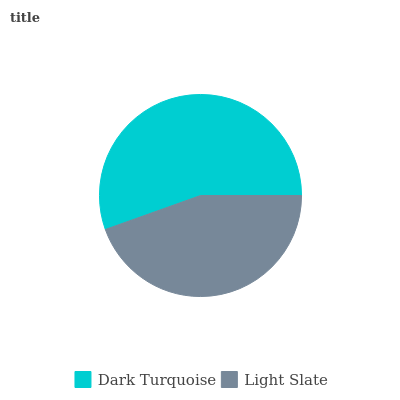Is Light Slate the minimum?
Answer yes or no. Yes. Is Dark Turquoise the maximum?
Answer yes or no. Yes. Is Light Slate the maximum?
Answer yes or no. No. Is Dark Turquoise greater than Light Slate?
Answer yes or no. Yes. Is Light Slate less than Dark Turquoise?
Answer yes or no. Yes. Is Light Slate greater than Dark Turquoise?
Answer yes or no. No. Is Dark Turquoise less than Light Slate?
Answer yes or no. No. Is Dark Turquoise the high median?
Answer yes or no. Yes. Is Light Slate the low median?
Answer yes or no. Yes. Is Light Slate the high median?
Answer yes or no. No. Is Dark Turquoise the low median?
Answer yes or no. No. 